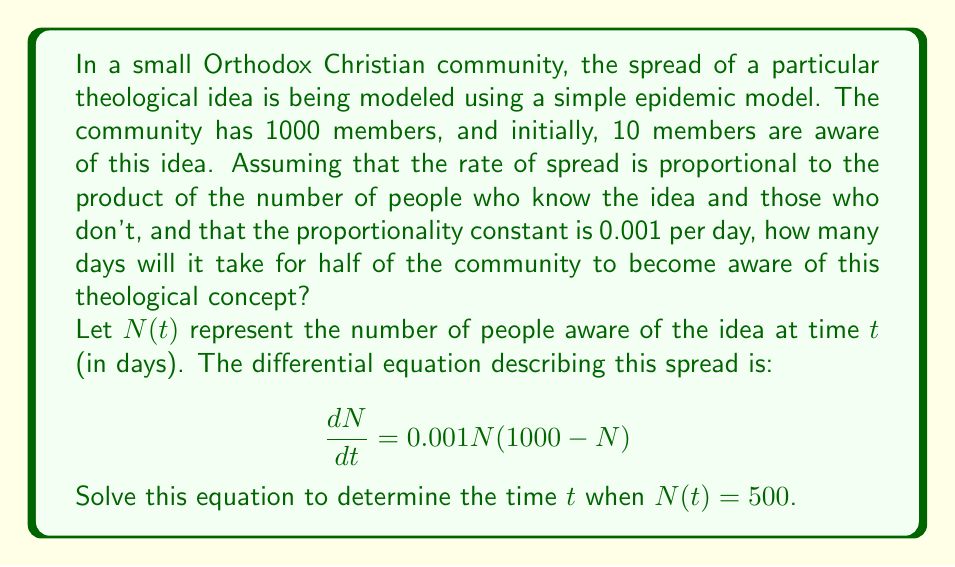Can you answer this question? To solve this problem, we'll use the logistic growth model, which is commonly used in epidemic modeling and can be applied to the spread of ideas as well.

1) The differential equation given is:

   $$\frac{dN}{dt} = 0.001N(1000-N)$$

2) This is a separable differential equation. We can rewrite it as:

   $$\frac{dN}{N(1000-N)} = 0.001dt$$

3) Integrating both sides:

   $$\int \frac{dN}{N(1000-N)} = \int 0.001dt$$

4) The left side can be integrated using partial fractions:

   $$\frac{1}{1000}\ln\left(\frac{N}{1000-N}\right) = 0.001t + C$$

5) We can determine the constant $C$ using the initial condition. At $t=0$, $N=10$:

   $$\frac{1}{1000}\ln\left(\frac{10}{990}\right) = C$$

6) Subtracting this from our general solution:

   $$\frac{1}{1000}\ln\left(\frac{N}{1000-N}\right) - \frac{1}{1000}\ln\left(\frac{10}{990}\right) = 0.001t$$

7) Simplifying:

   $$\ln\left(\frac{N}{1000-N} \cdot \frac{990}{10}\right) = t$$

8) We want to find $t$ when $N = 500$. Substituting this in:

   $$\ln\left(\frac{500}{500} \cdot \frac{990}{10}\right) = t$$

9) Simplifying:

   $$\ln(99) = t$$

10) Solving for $t$:

    $$t = \ln(99) \approx 4.5951$$

Therefore, it will take approximately 4.5951 days for half of the community to become aware of the theological concept.
Answer: $t \approx 4.5951$ days 